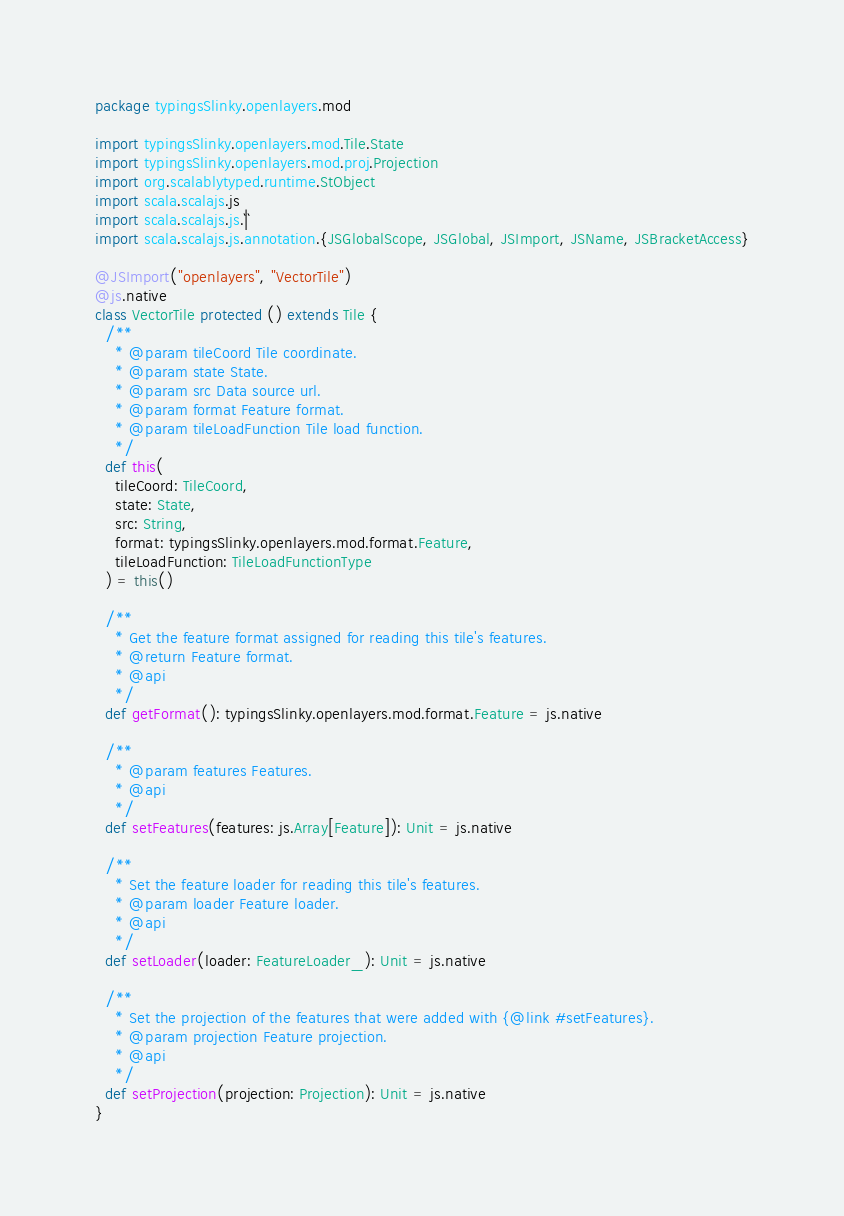<code> <loc_0><loc_0><loc_500><loc_500><_Scala_>package typingsSlinky.openlayers.mod

import typingsSlinky.openlayers.mod.Tile.State
import typingsSlinky.openlayers.mod.proj.Projection
import org.scalablytyped.runtime.StObject
import scala.scalajs.js
import scala.scalajs.js.`|`
import scala.scalajs.js.annotation.{JSGlobalScope, JSGlobal, JSImport, JSName, JSBracketAccess}

@JSImport("openlayers", "VectorTile")
@js.native
class VectorTile protected () extends Tile {
  /**
    * @param tileCoord Tile coordinate.
    * @param state State.
    * @param src Data source url.
    * @param format Feature format.
    * @param tileLoadFunction Tile load function.
    */
  def this(
    tileCoord: TileCoord,
    state: State,
    src: String,
    format: typingsSlinky.openlayers.mod.format.Feature,
    tileLoadFunction: TileLoadFunctionType
  ) = this()
  
  /**
    * Get the feature format assigned for reading this tile's features.
    * @return Feature format.
    * @api
    */
  def getFormat(): typingsSlinky.openlayers.mod.format.Feature = js.native
  
  /**
    * @param features Features.
    * @api
    */
  def setFeatures(features: js.Array[Feature]): Unit = js.native
  
  /**
    * Set the feature loader for reading this tile's features.
    * @param loader Feature loader.
    * @api
    */
  def setLoader(loader: FeatureLoader_): Unit = js.native
  
  /**
    * Set the projection of the features that were added with {@link #setFeatures}.
    * @param projection Feature projection.
    * @api
    */
  def setProjection(projection: Projection): Unit = js.native
}
</code> 